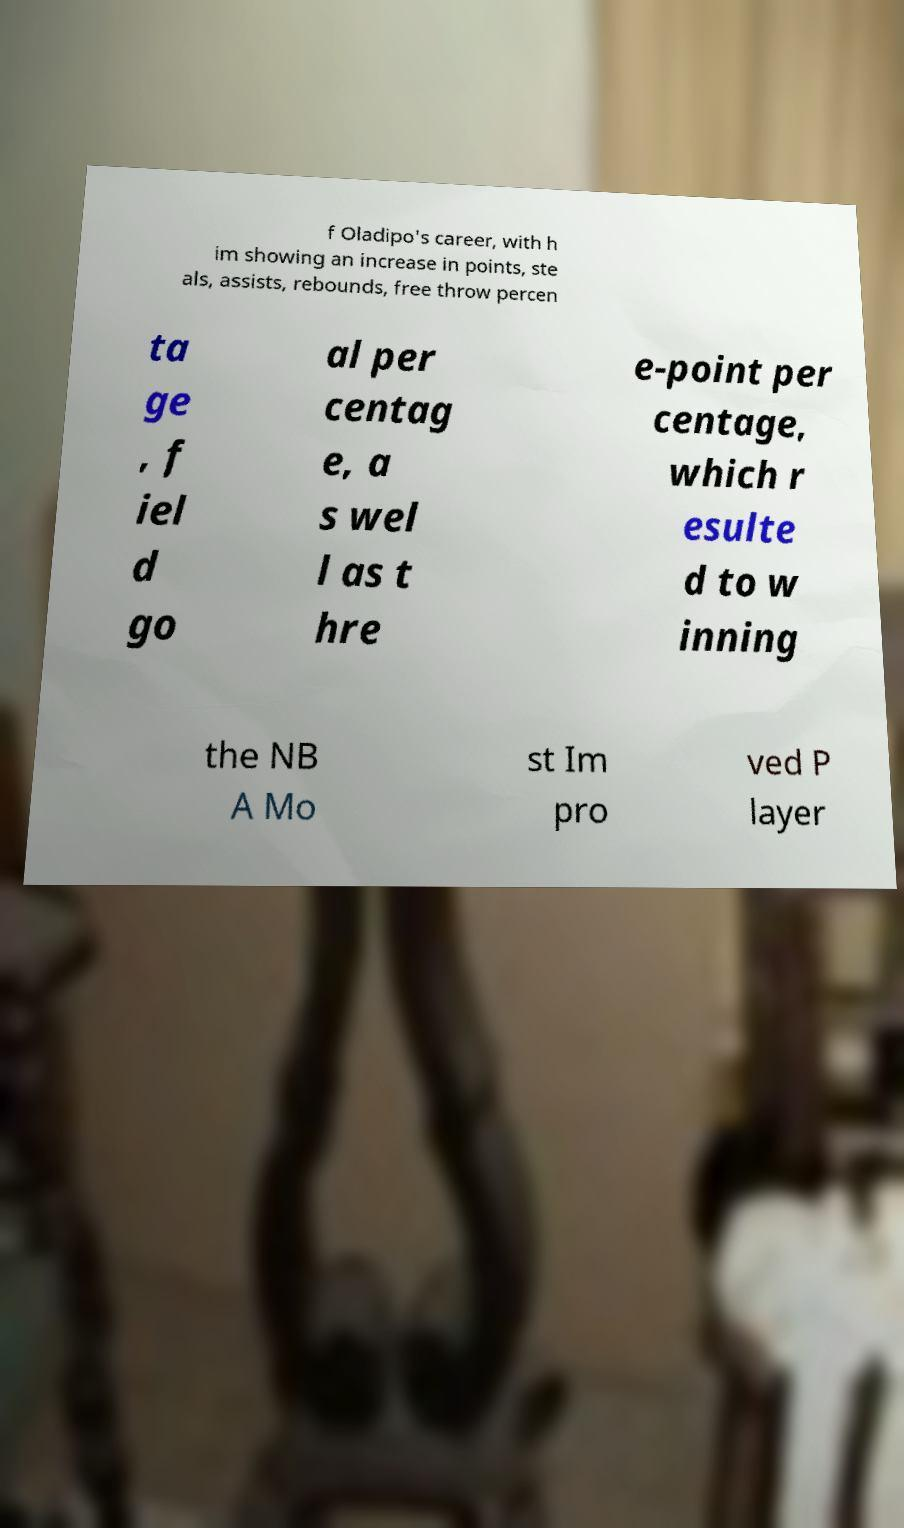Could you extract and type out the text from this image? f Oladipo's career, with h im showing an increase in points, ste als, assists, rebounds, free throw percen ta ge , f iel d go al per centag e, a s wel l as t hre e-point per centage, which r esulte d to w inning the NB A Mo st Im pro ved P layer 